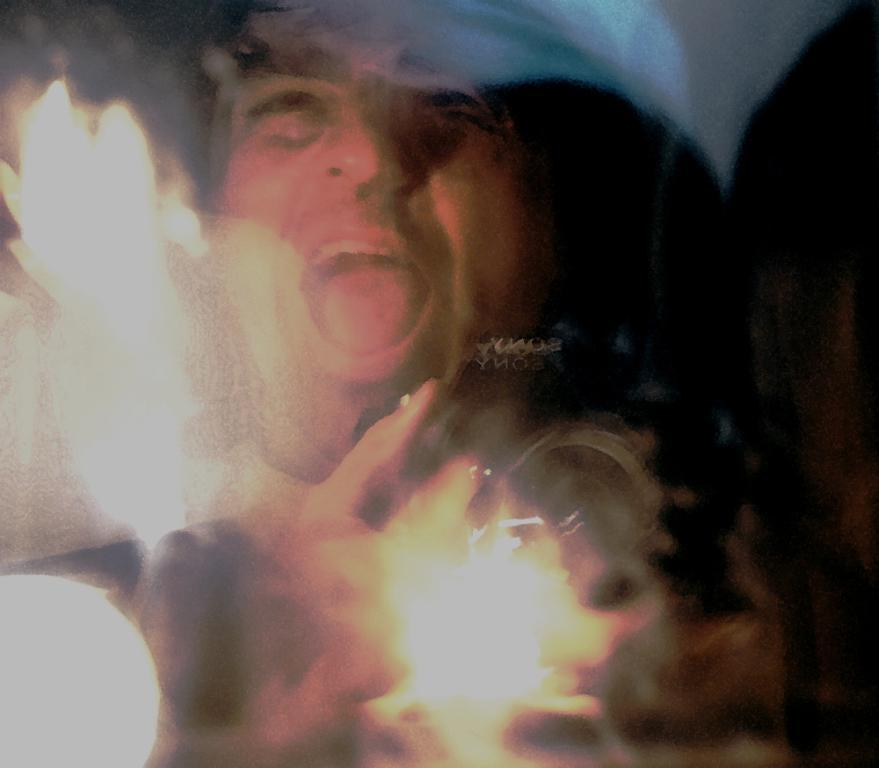What type of living being is present in the image? There is a human in the image. What is the primary element in the image? There appears to be fire in the image. How long does the trip take for the scissors in the image? There are no scissors present in the image, so it is not possible to determine the duration of any trip. 